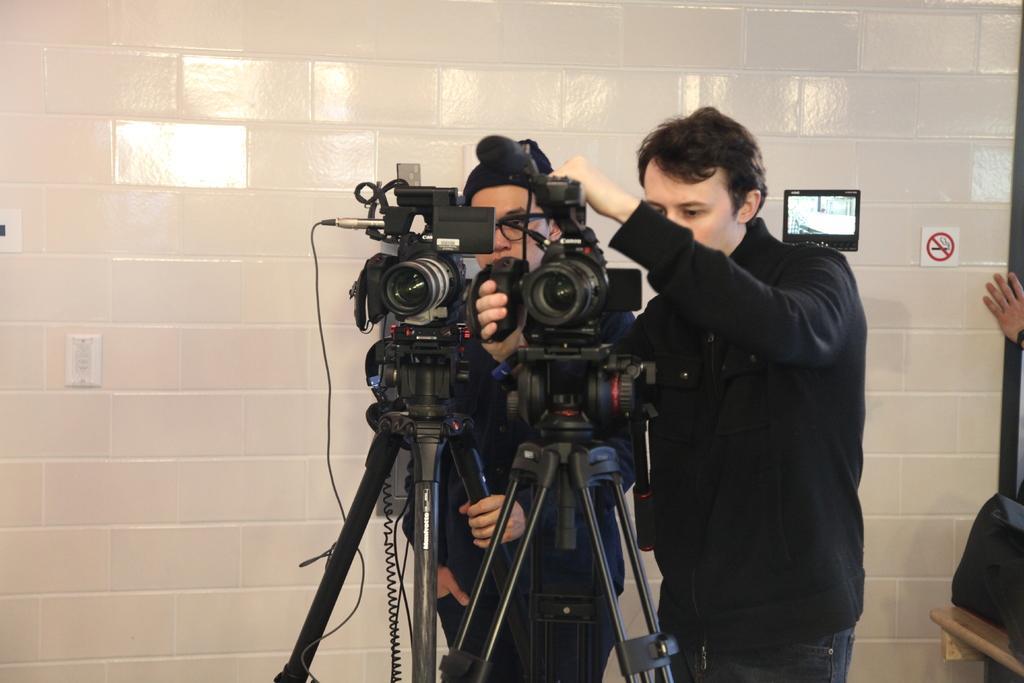Describe this image in one or two sentences. In this picture we can see two persons standing here, we can see two digital cameras and two tripods here, in the background there is a wall, we can see a sticker here, on the right side we can see another person's hand. 